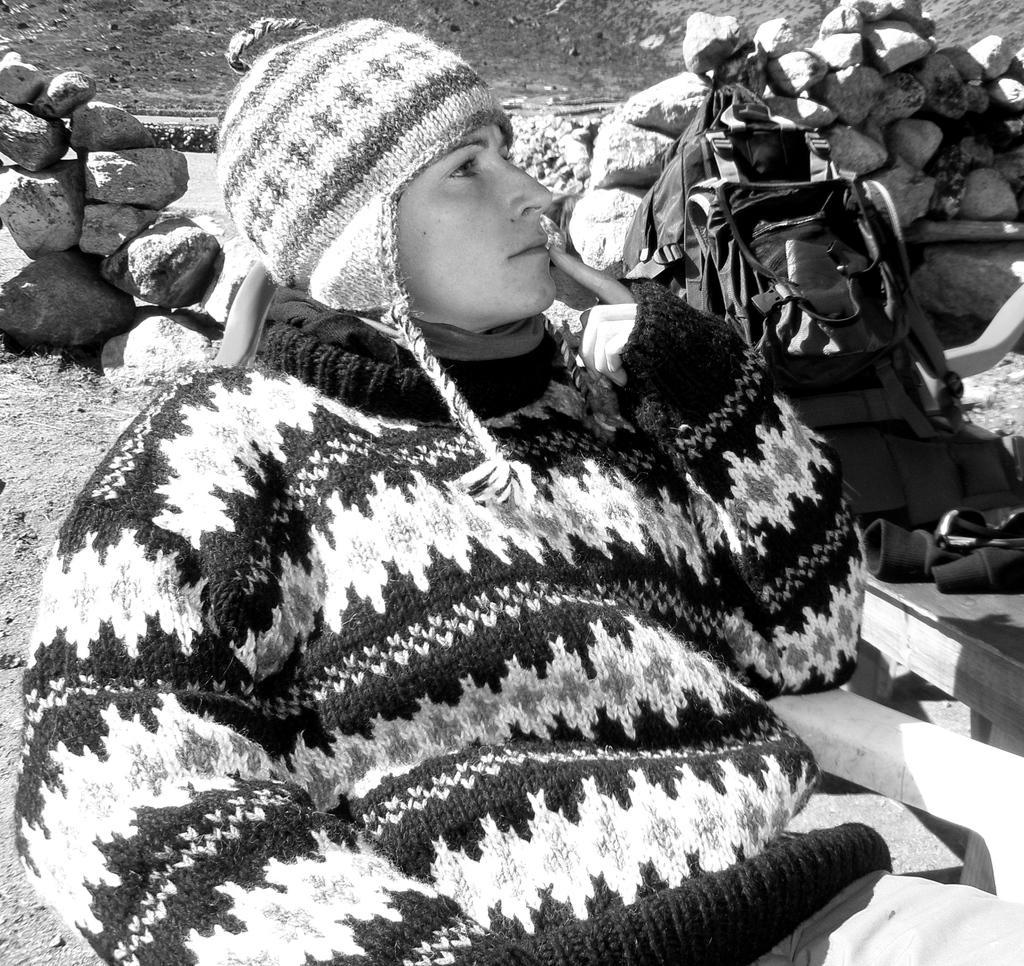Could you give a brief overview of what you see in this image? In the foreground of this black and white picture, there is a man wearing a sweater and a cap is sitting on a chair. In the background, there is a bag, spectacles and a jacket are on a bench and we can also see stones and a mountain slope. 